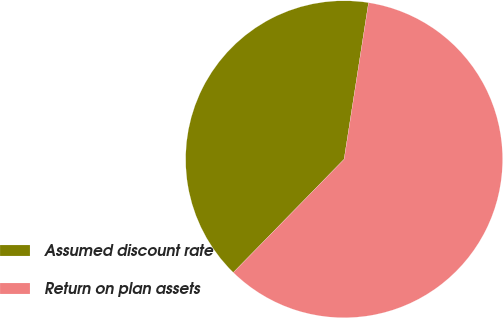<chart> <loc_0><loc_0><loc_500><loc_500><pie_chart><fcel>Assumed discount rate<fcel>Return on plan assets<nl><fcel>40.14%<fcel>59.86%<nl></chart> 